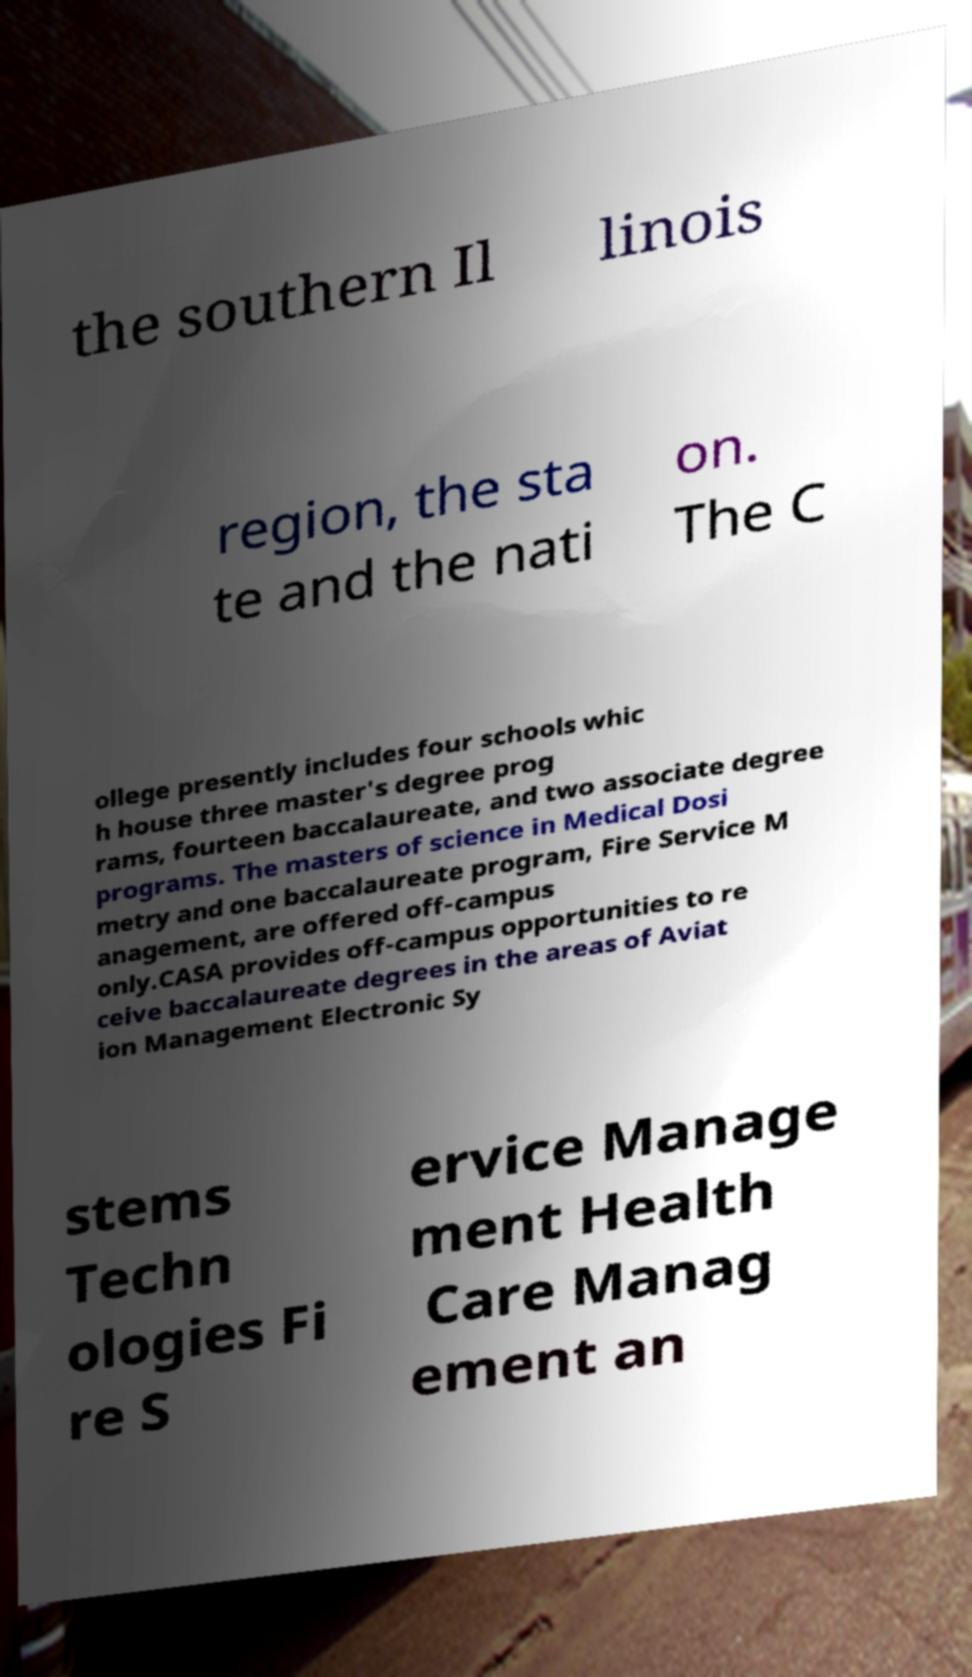For documentation purposes, I need the text within this image transcribed. Could you provide that? the southern Il linois region, the sta te and the nati on. The C ollege presently includes four schools whic h house three master's degree prog rams, fourteen baccalaureate, and two associate degree programs. The masters of science in Medical Dosi metry and one baccalaureate program, Fire Service M anagement, are offered off-campus only.CASA provides off-campus opportunities to re ceive baccalaureate degrees in the areas of Aviat ion Management Electronic Sy stems Techn ologies Fi re S ervice Manage ment Health Care Manag ement an 